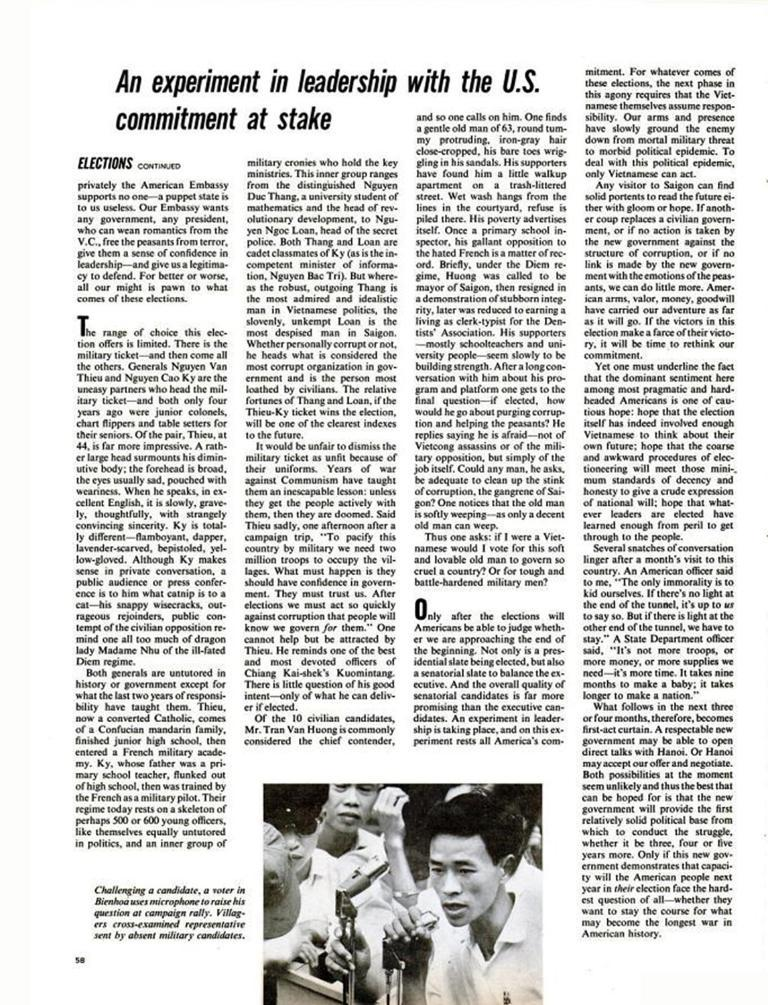What is the main subject of the image? The main subject of the image is a photo of a newspaper. What can be seen within the photo of the newspaper? There is a picture within the photo of the newspaper. What else is visible in the photo of the newspaper? There is text visible in the photo of the newspaper. How many family members are visible in the image? There are no family members visible in the image; it only contains a photo of a newspaper. What type of quiver is being used by the person in the image? There is no person or quiver present in the image; it only contains a photo of a newspaper. 